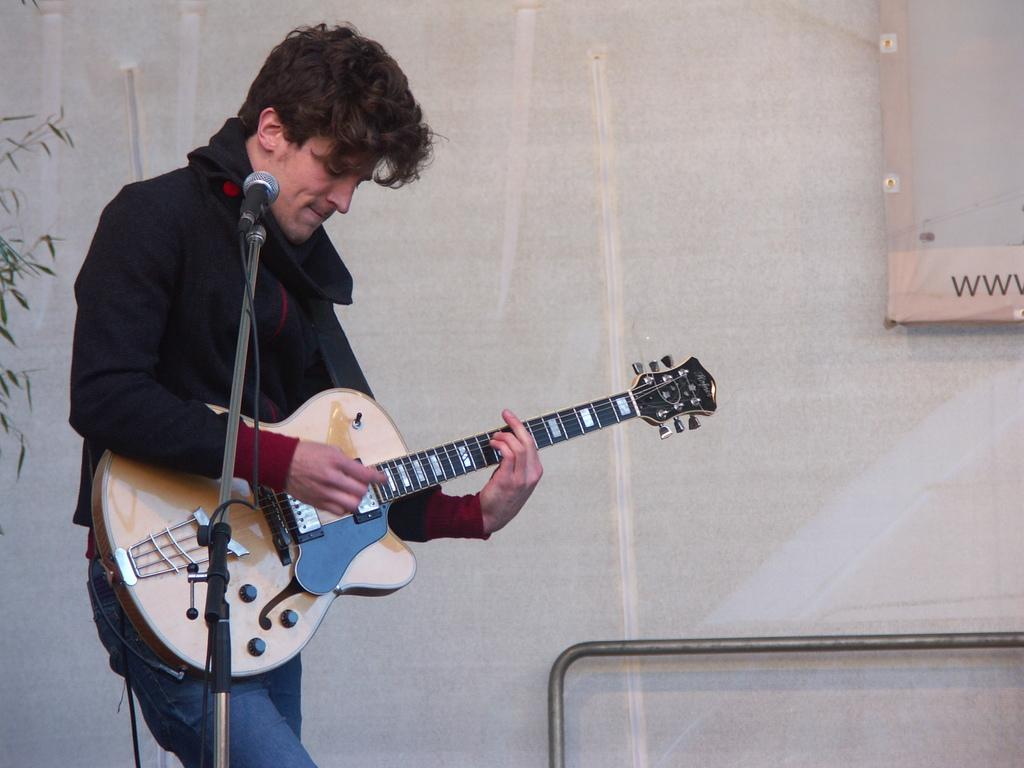What is the main object on the stand in the image? There is a mic on the stand in the image. What is connected to the mic? There is a wire connected to the mic. What is the man in the image doing? The man is standing and holding a guitar. What can be seen in the background of the image? There is a rod visible in the background. What type of vegetation is present on the left side of the image? Leaves are present on the left side of the image. How many beads are hanging from the guitar in the image? There are no beads hanging from the guitar in the image. What type of force is being applied to the mic in the image? There is no indication of any force being applied to the mic in the image; it is stationary on the stand. 